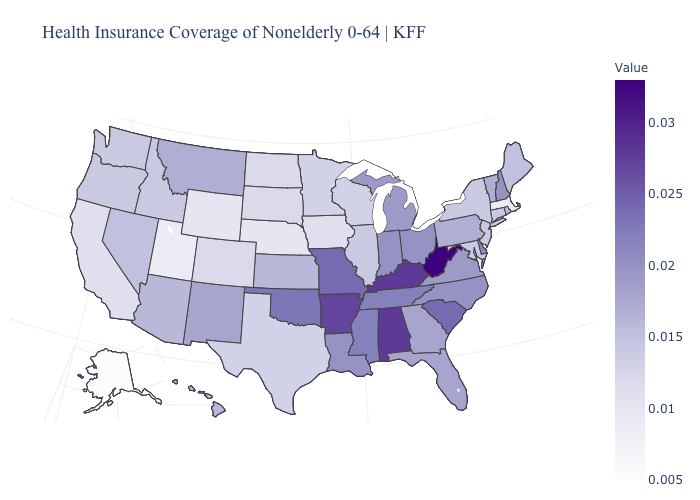Does Nebraska have the lowest value in the MidWest?
Keep it brief. Yes. Does North Dakota have the lowest value in the MidWest?
Give a very brief answer. No. Does Ohio have the highest value in the MidWest?
Write a very short answer. No. Does Pennsylvania have the lowest value in the Northeast?
Write a very short answer. No. 